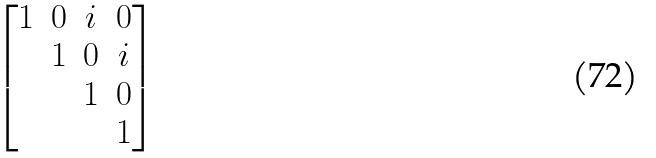Convert formula to latex. <formula><loc_0><loc_0><loc_500><loc_500>\begin{bmatrix} 1 & 0 & i & 0 \\ & 1 & 0 & i \\ & & 1 & 0 \\ & & & 1 \end{bmatrix}</formula> 